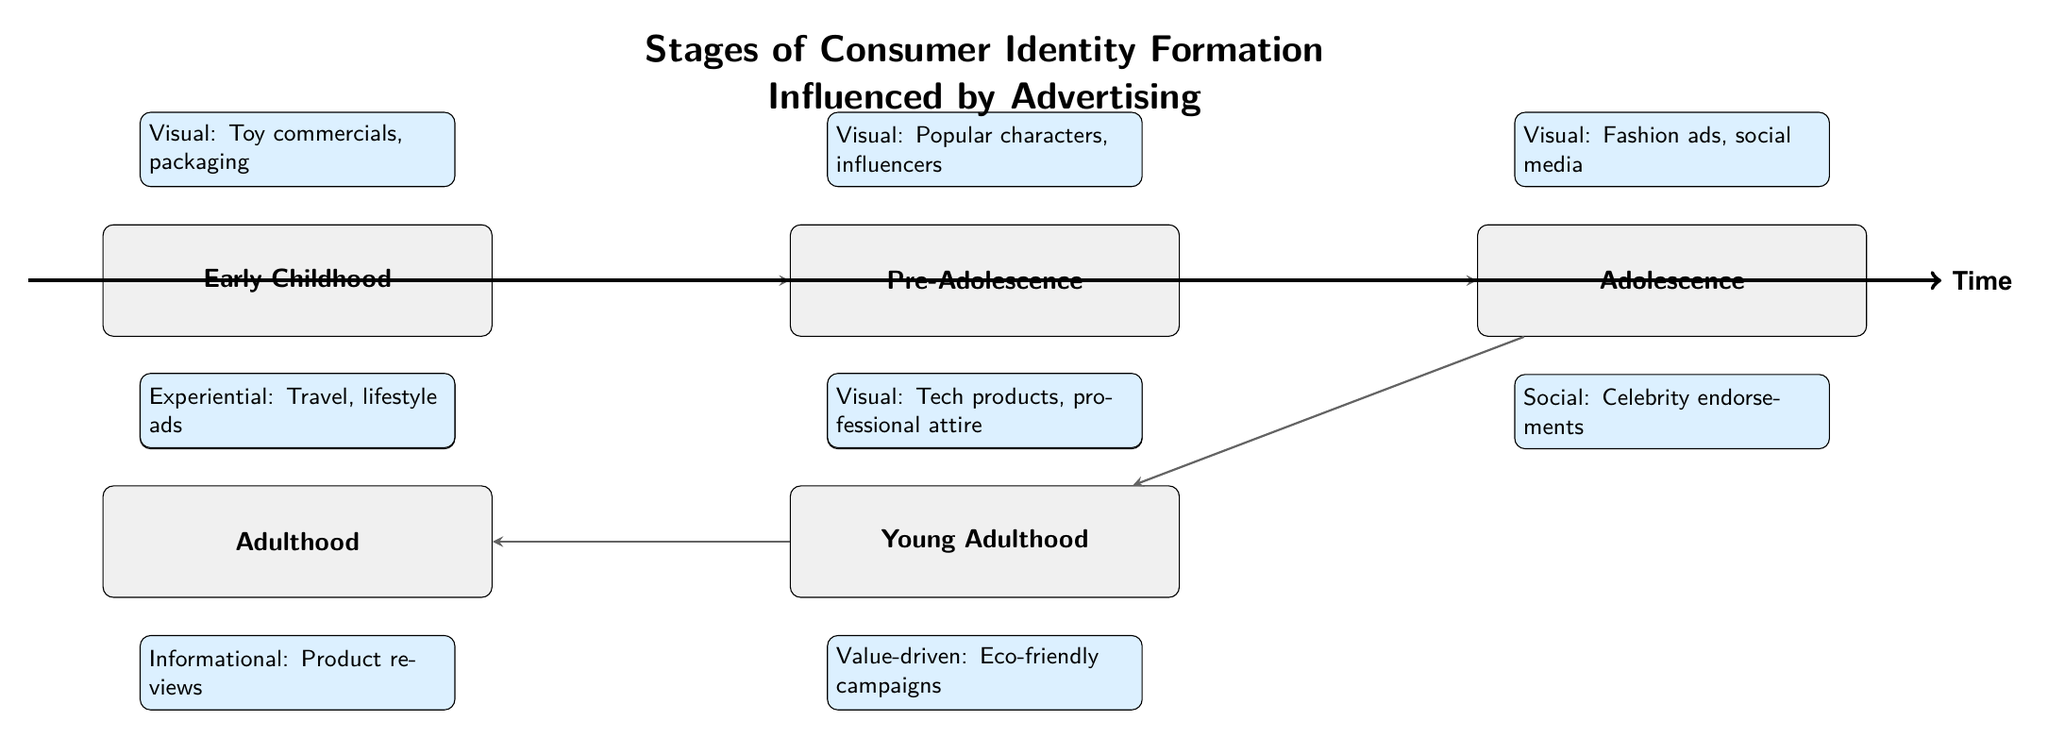What are the stages of consumer identity formation shown in the diagram? The diagram lists five stages: Early Childhood, Pre-Adolescence, Adolescence, Young Adulthood, and Adulthood.
Answer: Early Childhood, Pre-Adolescence, Adolescence, Young Adulthood, Adulthood How many influence types are associated with Early Childhood? There are two influence types listed related to Early Childhood: Visual and Auditory.
Answer: 2 What are the visual influences for Young Adulthood? The diagram indicates that the visual influences for Young Adulthood are Tech products and professional attire.
Answer: Tech products, professional attire Which stage is influenced by social media? Adolescence is the stage influenced by social media, as indicated under the influence types for that stage.
Answer: Adolescence What type of influence is associated with Adulthood? The diagram identifies two types of influences associated with Adulthood: Experiential and Informational.
Answer: Experiential, Informational What is the relationship between Pre-Adolescence and Adolescence? The diagram shows a direct arrow from Pre-Adolescence to Adolescence, indicating a progression from one stage to the next.
Answer: Direct progression List the environmental influence for Pre-Adolescence. The environmental influence indicated for Pre-Adolescence is in-store displays.
Answer: In-store displays In what direction does the timeline flow? The timeline flows from left to right, with an arrow indicating the passage of time from Early Childhood to Adulthood.
Answer: Left to right 